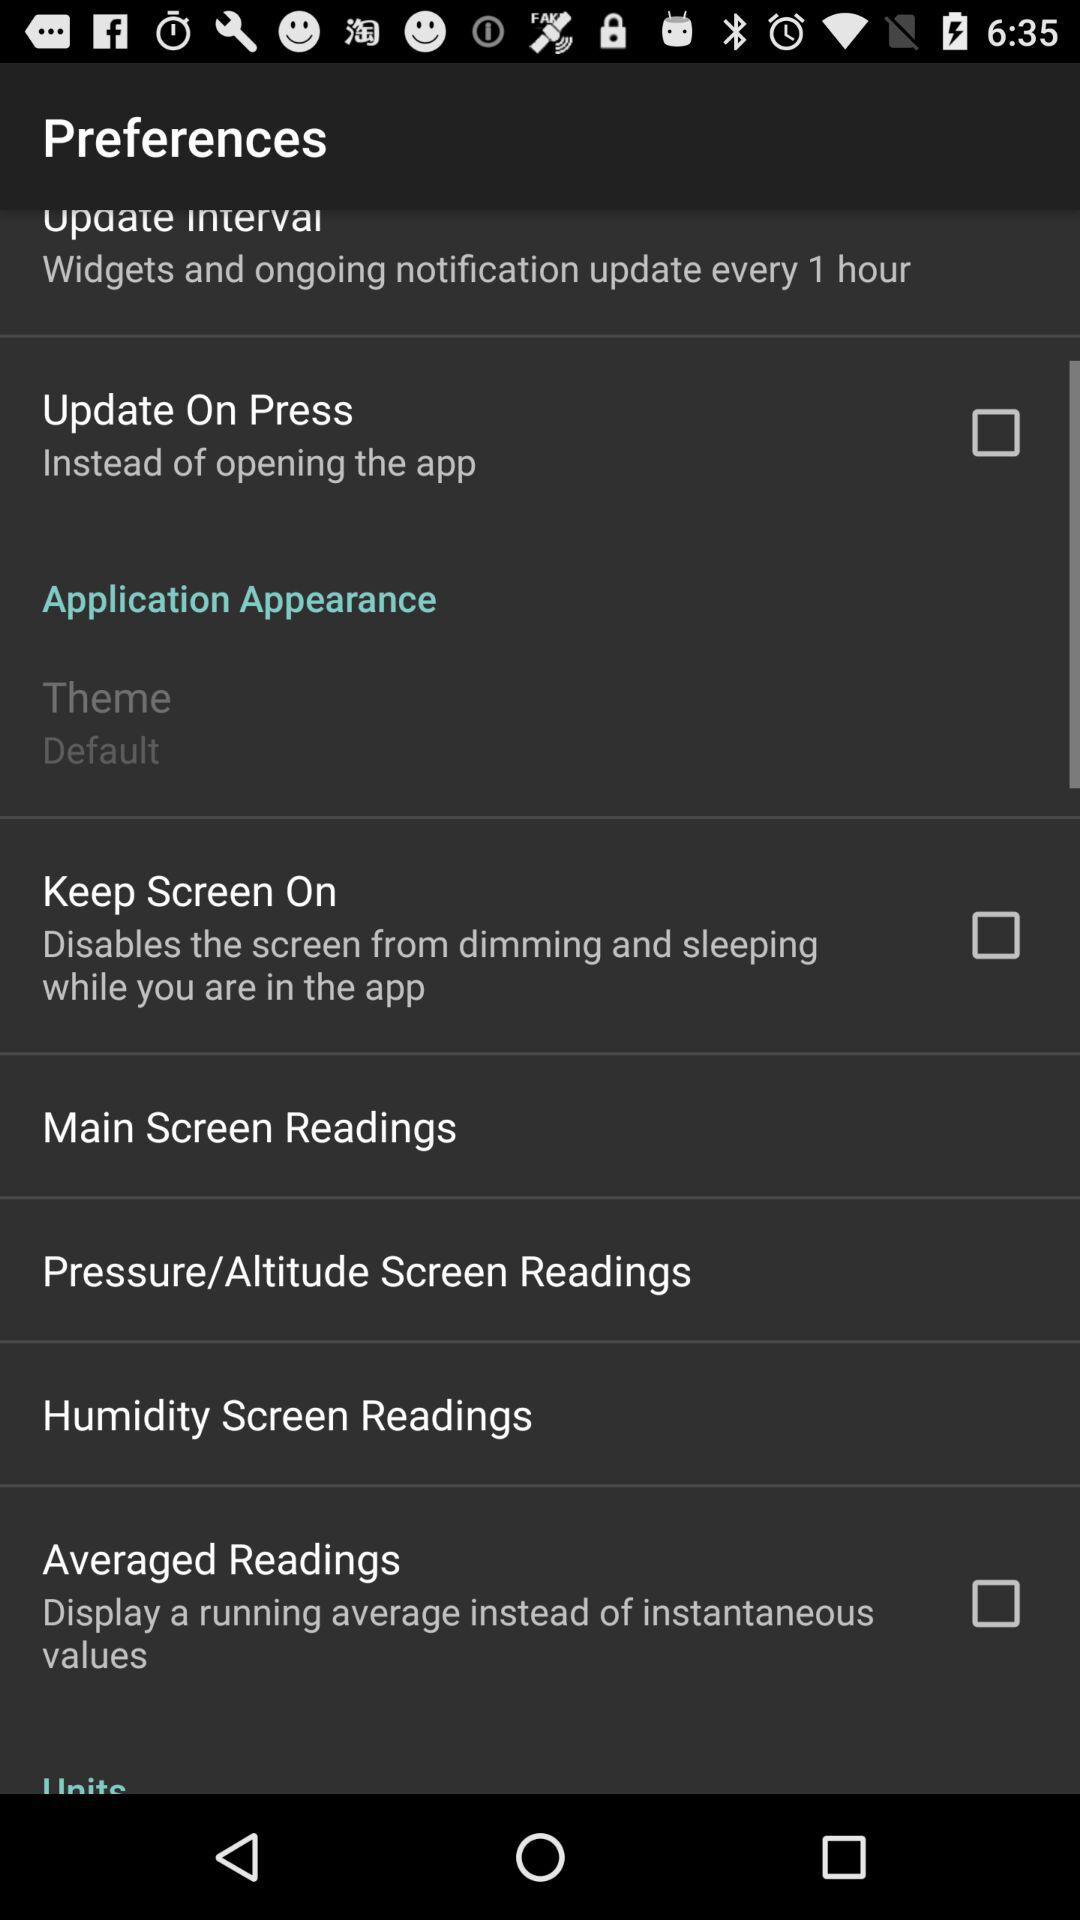What is the status of the "Keep Screen On"? The status is "off". 